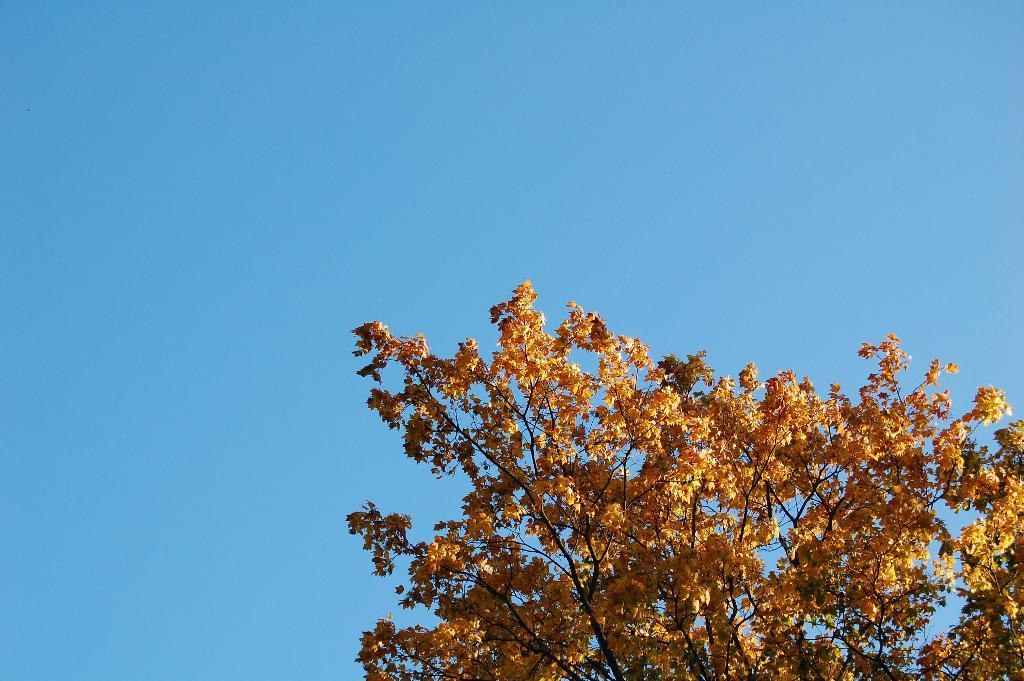What type of vegetation is on the right side of the image? There are trees on the right side of the image. What is visible in the background of the image? The sky is visible in the image. What type of knot is used to secure the nest in the canvas in the image? There is no knot, nest, or canvas present in the image. 